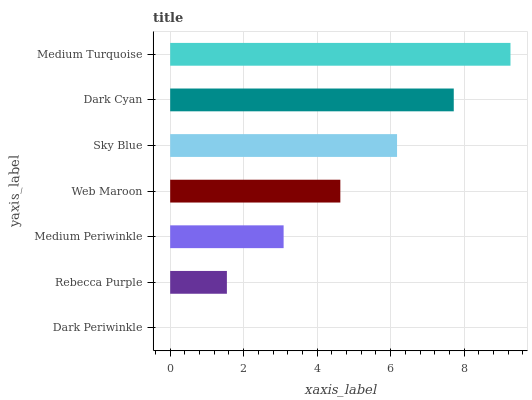Is Dark Periwinkle the minimum?
Answer yes or no. Yes. Is Medium Turquoise the maximum?
Answer yes or no. Yes. Is Rebecca Purple the minimum?
Answer yes or no. No. Is Rebecca Purple the maximum?
Answer yes or no. No. Is Rebecca Purple greater than Dark Periwinkle?
Answer yes or no. Yes. Is Dark Periwinkle less than Rebecca Purple?
Answer yes or no. Yes. Is Dark Periwinkle greater than Rebecca Purple?
Answer yes or no. No. Is Rebecca Purple less than Dark Periwinkle?
Answer yes or no. No. Is Web Maroon the high median?
Answer yes or no. Yes. Is Web Maroon the low median?
Answer yes or no. Yes. Is Sky Blue the high median?
Answer yes or no. No. Is Medium Turquoise the low median?
Answer yes or no. No. 